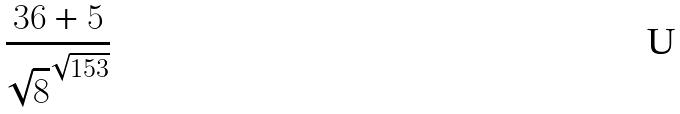Convert formula to latex. <formula><loc_0><loc_0><loc_500><loc_500>\frac { 3 6 + 5 } { \sqrt { 8 } ^ { \sqrt { 1 5 3 } } }</formula> 